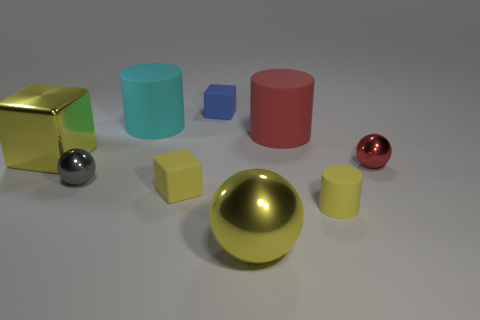Add 1 small purple cylinders. How many objects exist? 10 Subtract all cylinders. How many objects are left? 6 Subtract 0 cyan cubes. How many objects are left? 9 Subtract all tiny blue rubber things. Subtract all yellow cylinders. How many objects are left? 7 Add 5 matte cylinders. How many matte cylinders are left? 8 Add 6 small blue metallic objects. How many small blue metallic objects exist? 6 